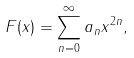<formula> <loc_0><loc_0><loc_500><loc_500>F ( x ) = \sum ^ { \infty } _ { n = 0 } a _ { n } x ^ { 2 n } ,</formula> 